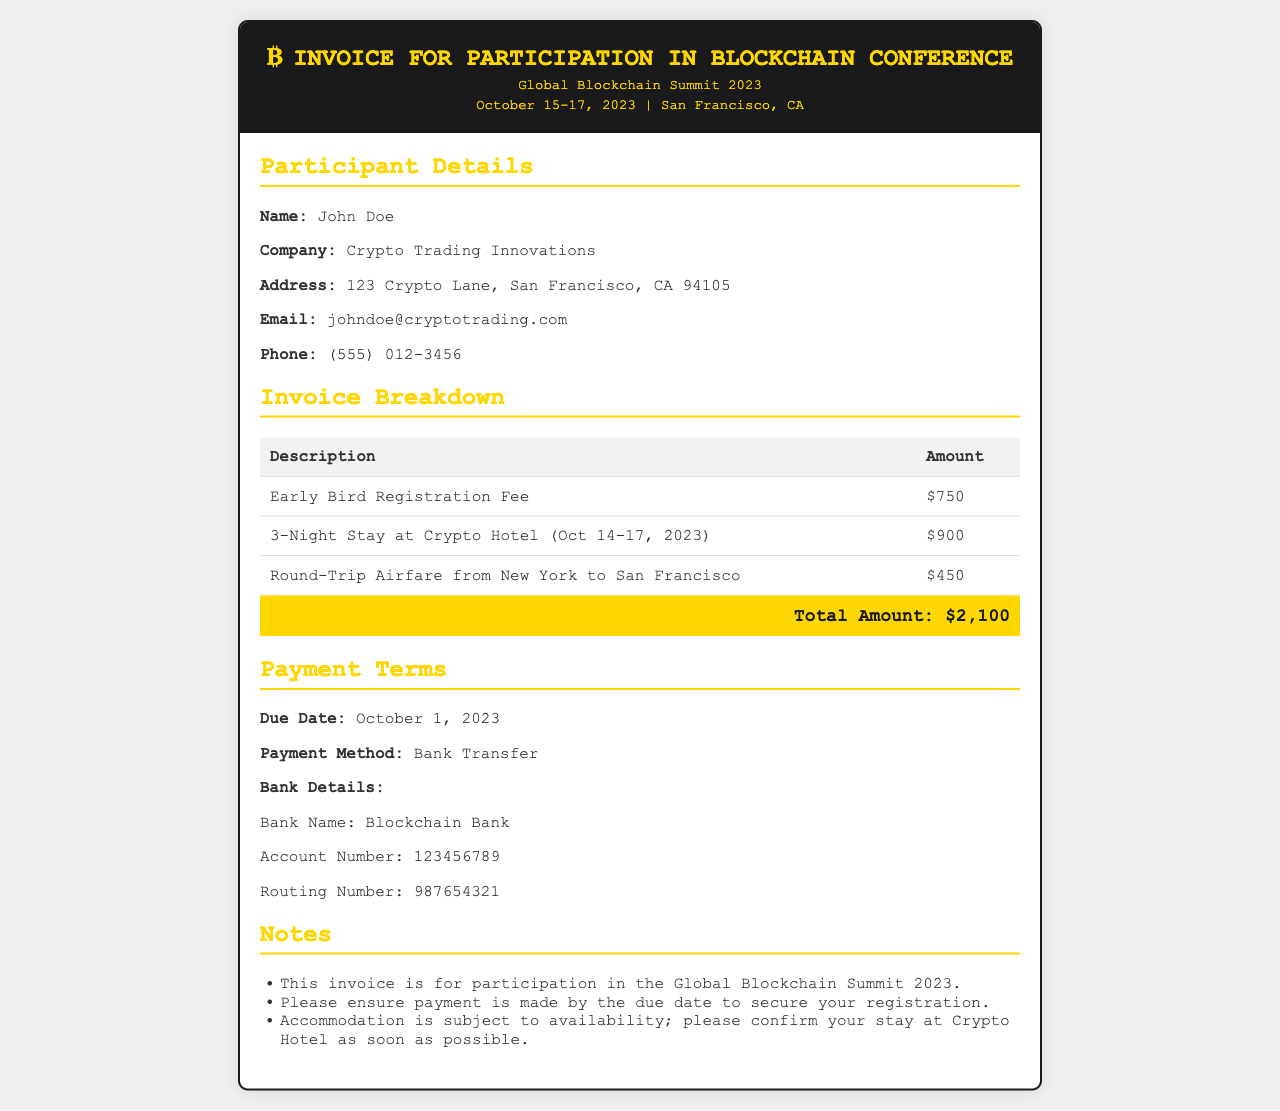What is the total amount due? The total amount is found in the breakdown section of the invoice, which lists the cumulative fees for the event.
Answer: $2,100 What is the registration fee? The registration fee is specified in the invoice breakdown under "Early Bird Registration Fee."
Answer: $750 What dates is the conference held? The conference dates are listed in the header of the document.
Answer: October 15-17, 2023 Who is the participant? The participant's name can be found in the participant details section of the document.
Answer: John Doe What is the check-in date at the hotel? The hotel's dates are mentioned in the breakdown section, which includes the duration of the stay.
Answer: October 14, 2023 When is the payment due? The due date for the payment is stated in the payment terms section of the invoice.
Answer: October 1, 2023 What is the accommodation cost? The accommodation cost is detailed in the breakdown section of the invoice.
Answer: $900 How should the payment be made? The method of payment is outlined in the payment terms.
Answer: Bank Transfer What is the hotel name? The hotel name is specified in the breakdown section under accommodation details.
Answer: Crypto Hotel 